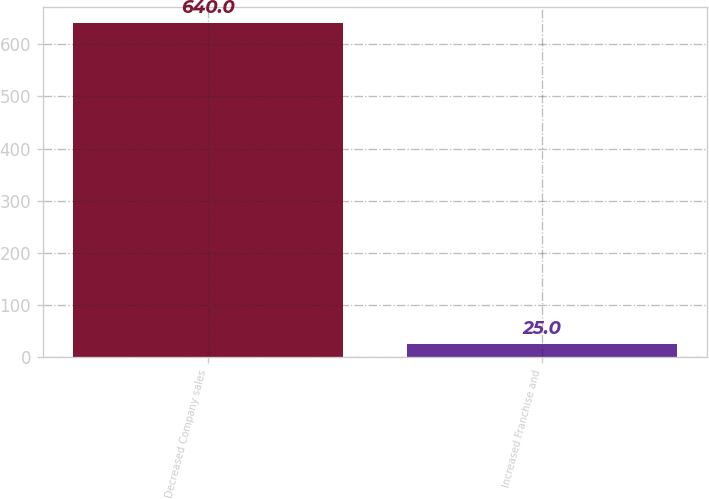Convert chart. <chart><loc_0><loc_0><loc_500><loc_500><bar_chart><fcel>Decreased Company sales<fcel>Increased Franchise and<nl><fcel>640<fcel>25<nl></chart> 